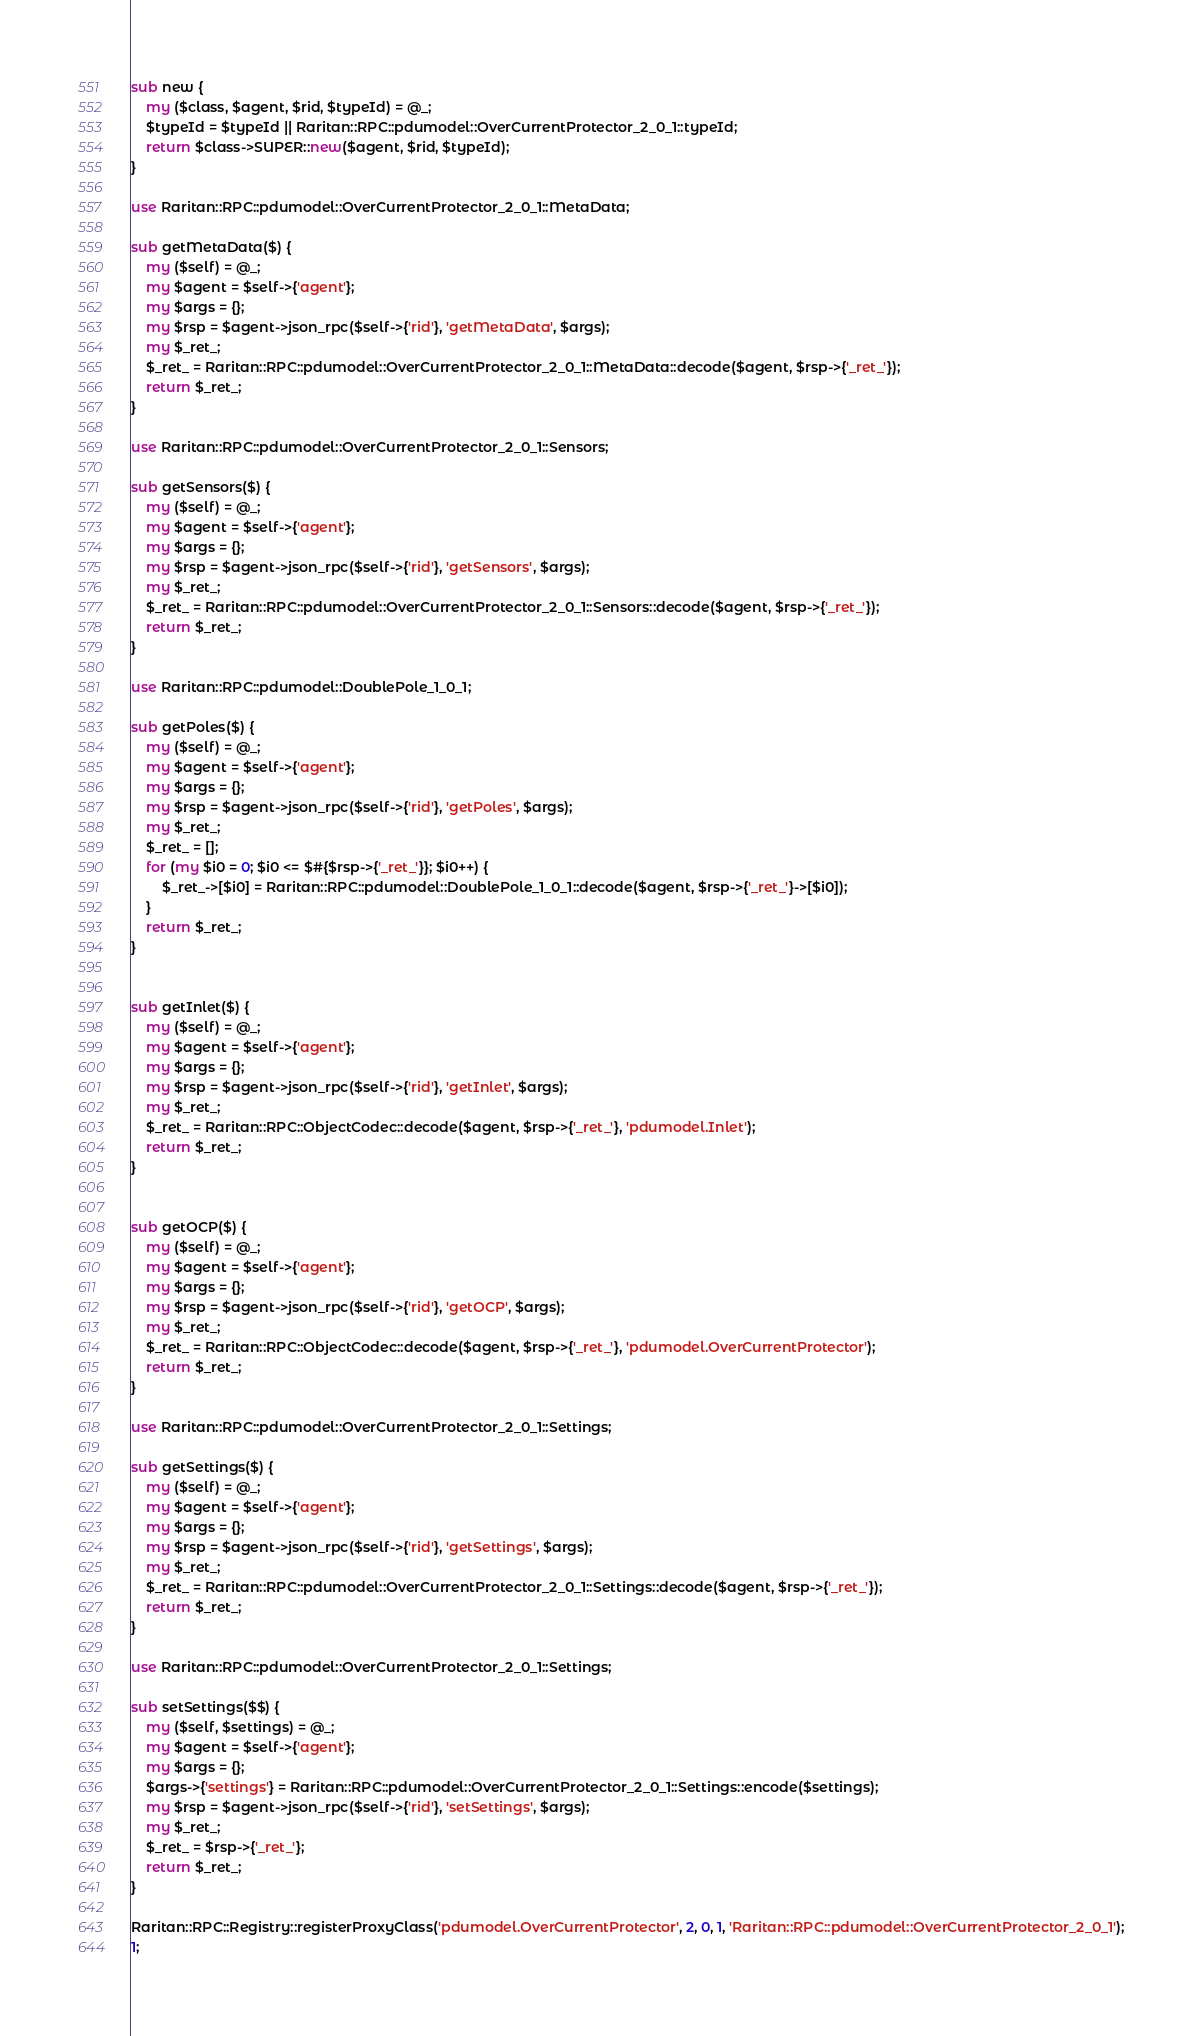Convert code to text. <code><loc_0><loc_0><loc_500><loc_500><_Perl_>
sub new {
    my ($class, $agent, $rid, $typeId) = @_;
    $typeId = $typeId || Raritan::RPC::pdumodel::OverCurrentProtector_2_0_1::typeId;
    return $class->SUPER::new($agent, $rid, $typeId);
}

use Raritan::RPC::pdumodel::OverCurrentProtector_2_0_1::MetaData;

sub getMetaData($) {
    my ($self) = @_;
    my $agent = $self->{'agent'};
    my $args = {};
    my $rsp = $agent->json_rpc($self->{'rid'}, 'getMetaData', $args);
    my $_ret_;
    $_ret_ = Raritan::RPC::pdumodel::OverCurrentProtector_2_0_1::MetaData::decode($agent, $rsp->{'_ret_'});
    return $_ret_;
}

use Raritan::RPC::pdumodel::OverCurrentProtector_2_0_1::Sensors;

sub getSensors($) {
    my ($self) = @_;
    my $agent = $self->{'agent'};
    my $args = {};
    my $rsp = $agent->json_rpc($self->{'rid'}, 'getSensors', $args);
    my $_ret_;
    $_ret_ = Raritan::RPC::pdumodel::OverCurrentProtector_2_0_1::Sensors::decode($agent, $rsp->{'_ret_'});
    return $_ret_;
}

use Raritan::RPC::pdumodel::DoublePole_1_0_1;

sub getPoles($) {
    my ($self) = @_;
    my $agent = $self->{'agent'};
    my $args = {};
    my $rsp = $agent->json_rpc($self->{'rid'}, 'getPoles', $args);
    my $_ret_;
    $_ret_ = [];
    for (my $i0 = 0; $i0 <= $#{$rsp->{'_ret_'}}; $i0++) {
        $_ret_->[$i0] = Raritan::RPC::pdumodel::DoublePole_1_0_1::decode($agent, $rsp->{'_ret_'}->[$i0]);
    }
    return $_ret_;
}


sub getInlet($) {
    my ($self) = @_;
    my $agent = $self->{'agent'};
    my $args = {};
    my $rsp = $agent->json_rpc($self->{'rid'}, 'getInlet', $args);
    my $_ret_;
    $_ret_ = Raritan::RPC::ObjectCodec::decode($agent, $rsp->{'_ret_'}, 'pdumodel.Inlet');
    return $_ret_;
}


sub getOCP($) {
    my ($self) = @_;
    my $agent = $self->{'agent'};
    my $args = {};
    my $rsp = $agent->json_rpc($self->{'rid'}, 'getOCP', $args);
    my $_ret_;
    $_ret_ = Raritan::RPC::ObjectCodec::decode($agent, $rsp->{'_ret_'}, 'pdumodel.OverCurrentProtector');
    return $_ret_;
}

use Raritan::RPC::pdumodel::OverCurrentProtector_2_0_1::Settings;

sub getSettings($) {
    my ($self) = @_;
    my $agent = $self->{'agent'};
    my $args = {};
    my $rsp = $agent->json_rpc($self->{'rid'}, 'getSettings', $args);
    my $_ret_;
    $_ret_ = Raritan::RPC::pdumodel::OverCurrentProtector_2_0_1::Settings::decode($agent, $rsp->{'_ret_'});
    return $_ret_;
}

use Raritan::RPC::pdumodel::OverCurrentProtector_2_0_1::Settings;

sub setSettings($$) {
    my ($self, $settings) = @_;
    my $agent = $self->{'agent'};
    my $args = {};
    $args->{'settings'} = Raritan::RPC::pdumodel::OverCurrentProtector_2_0_1::Settings::encode($settings);
    my $rsp = $agent->json_rpc($self->{'rid'}, 'setSettings', $args);
    my $_ret_;
    $_ret_ = $rsp->{'_ret_'};
    return $_ret_;
}

Raritan::RPC::Registry::registerProxyClass('pdumodel.OverCurrentProtector', 2, 0, 1, 'Raritan::RPC::pdumodel::OverCurrentProtector_2_0_1');
1;
</code> 